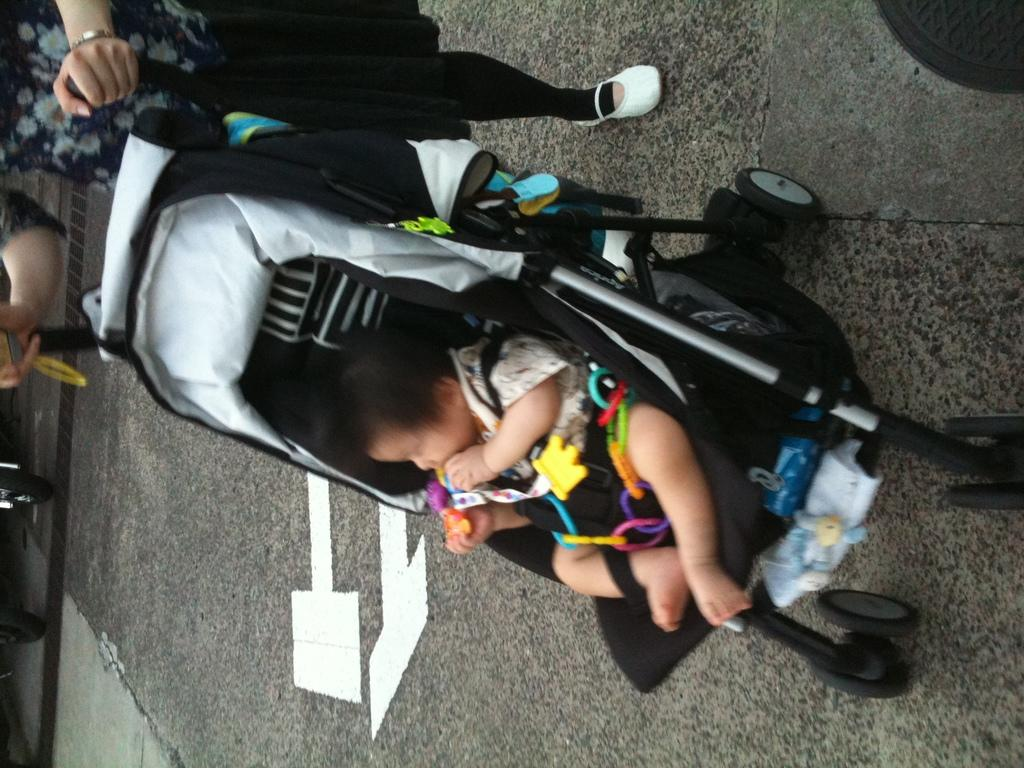What is the main subject in the buggy in the image? There is a baby in the buggy. What position is the baby in the buggy? The baby is sitting in the buggy. Who is standing near the buggy in the image? There is a woman standing on the road. What is the woman doing with the buggy? The woman is holding the handle of the buggy. What type of cherries can be seen growing on the handle of the buggy? There are no cherries present in the image, and they are not growing on the handle of the buggy. 